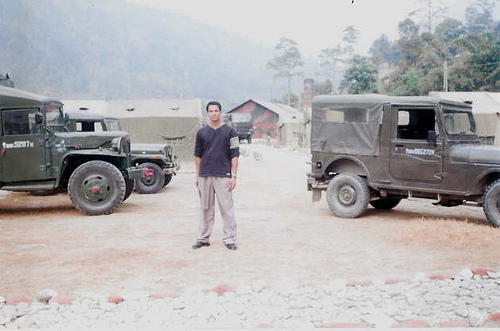What does the attire of the person suggest about the local climate? The person is dressed in casual, long-sleeved attire, suggesting that the climate might be mild to cool. Their clothing isn't heavy winter gear, which implies it's not extremely cold, but they're also not in short sleeves or lightweight fabric that would suggest a hot climate. 